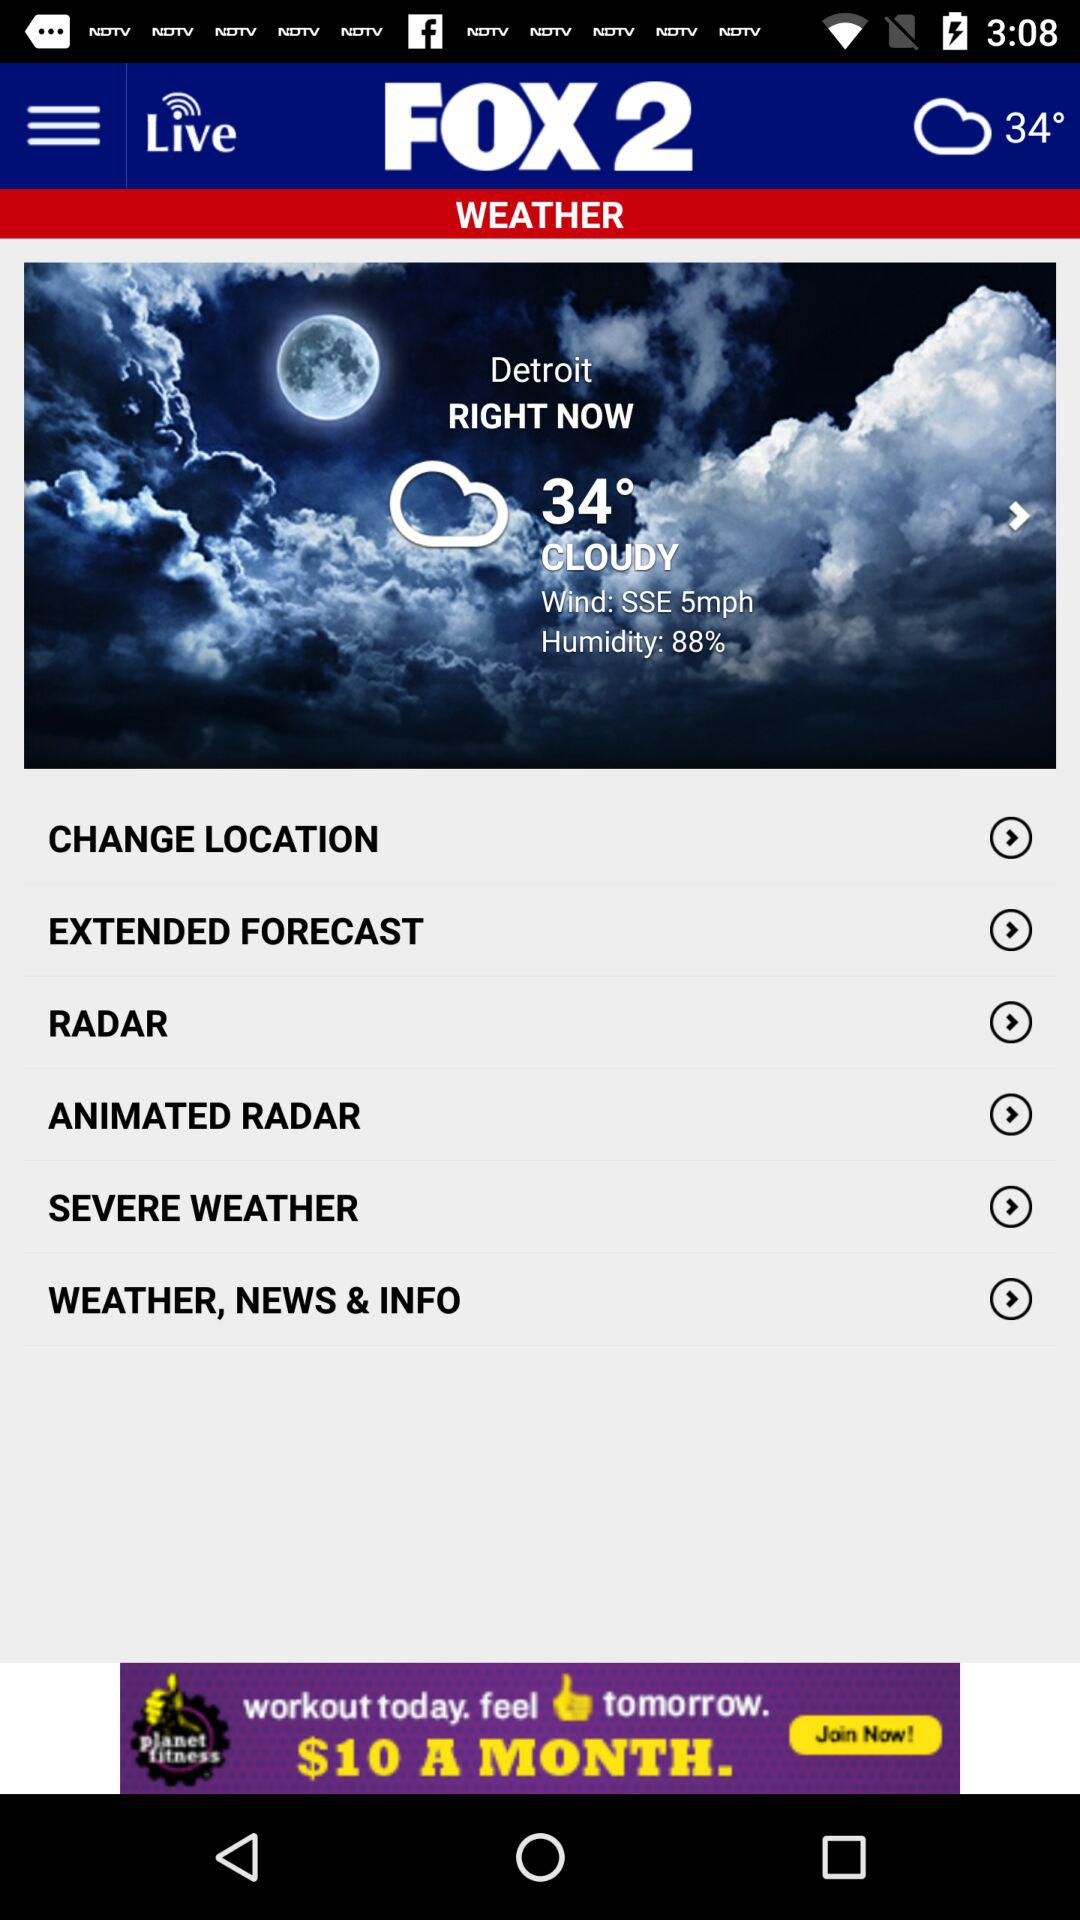What is the selected city? The selected city is "Detroit". 